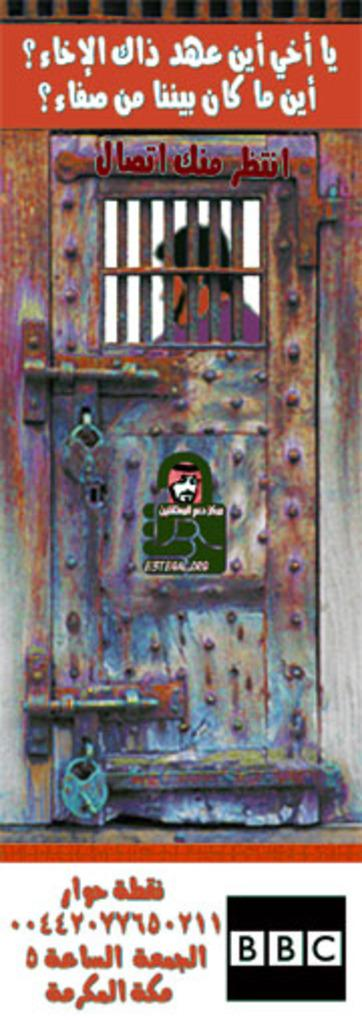Provide a one-sentence caption for the provided image. A scene from a BBC show has writing in a foreign language on it. 